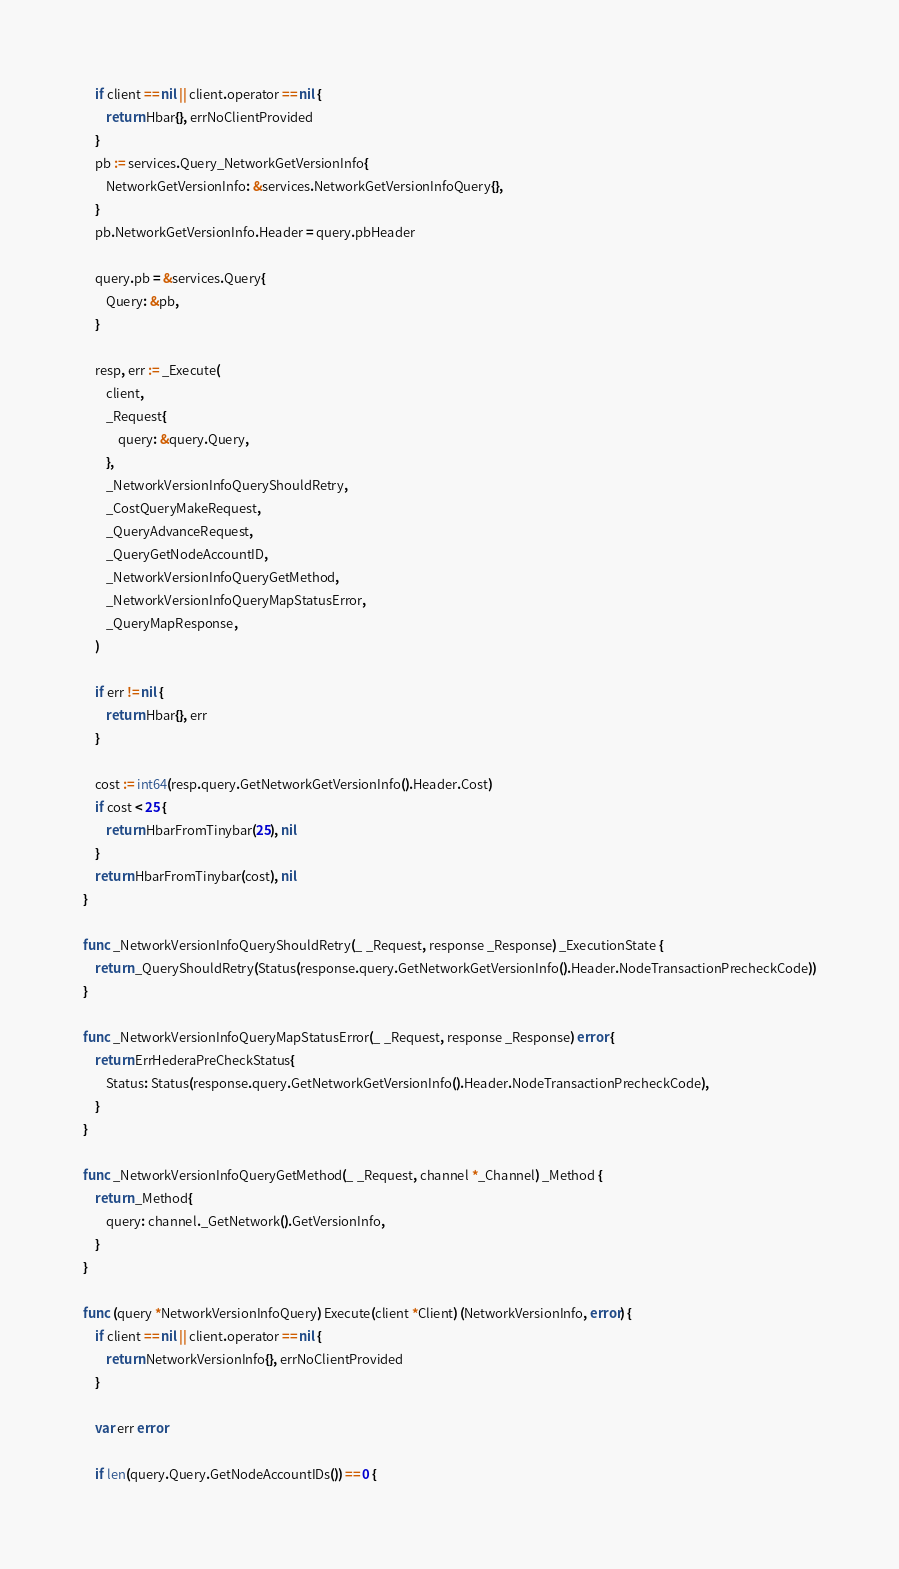Convert code to text. <code><loc_0><loc_0><loc_500><loc_500><_Go_>	if client == nil || client.operator == nil {
		return Hbar{}, errNoClientProvided
	}
	pb := services.Query_NetworkGetVersionInfo{
		NetworkGetVersionInfo: &services.NetworkGetVersionInfoQuery{},
	}
	pb.NetworkGetVersionInfo.Header = query.pbHeader

	query.pb = &services.Query{
		Query: &pb,
	}

	resp, err := _Execute(
		client,
		_Request{
			query: &query.Query,
		},
		_NetworkVersionInfoQueryShouldRetry,
		_CostQueryMakeRequest,
		_QueryAdvanceRequest,
		_QueryGetNodeAccountID,
		_NetworkVersionInfoQueryGetMethod,
		_NetworkVersionInfoQueryMapStatusError,
		_QueryMapResponse,
	)

	if err != nil {
		return Hbar{}, err
	}

	cost := int64(resp.query.GetNetworkGetVersionInfo().Header.Cost)
	if cost < 25 {
		return HbarFromTinybar(25), nil
	}
	return HbarFromTinybar(cost), nil
}

func _NetworkVersionInfoQueryShouldRetry(_ _Request, response _Response) _ExecutionState {
	return _QueryShouldRetry(Status(response.query.GetNetworkGetVersionInfo().Header.NodeTransactionPrecheckCode))
}

func _NetworkVersionInfoQueryMapStatusError(_ _Request, response _Response) error {
	return ErrHederaPreCheckStatus{
		Status: Status(response.query.GetNetworkGetVersionInfo().Header.NodeTransactionPrecheckCode),
	}
}

func _NetworkVersionInfoQueryGetMethod(_ _Request, channel *_Channel) _Method {
	return _Method{
		query: channel._GetNetwork().GetVersionInfo,
	}
}

func (query *NetworkVersionInfoQuery) Execute(client *Client) (NetworkVersionInfo, error) {
	if client == nil || client.operator == nil {
		return NetworkVersionInfo{}, errNoClientProvided
	}

	var err error

	if len(query.Query.GetNodeAccountIDs()) == 0 {</code> 